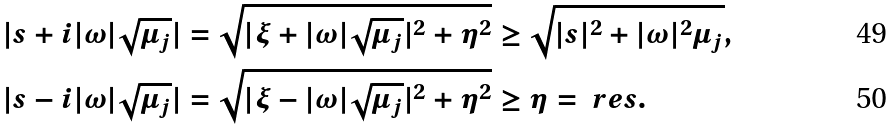<formula> <loc_0><loc_0><loc_500><loc_500>| s + i | \omega | \sqrt { \mu _ { j } } | & = \sqrt { | \xi + | \omega | \sqrt { \mu _ { j } } | ^ { 2 } + \eta ^ { 2 } } \geq \sqrt { | s | ^ { 2 } + | \omega | ^ { 2 } \mu _ { j } } , \\ | s - i | \omega | \sqrt { \mu _ { j } } | & = \sqrt { | \xi - | \omega | \sqrt { \mu _ { j } } | ^ { 2 } + \eta ^ { 2 } } \geq \eta = \ r e s .</formula> 